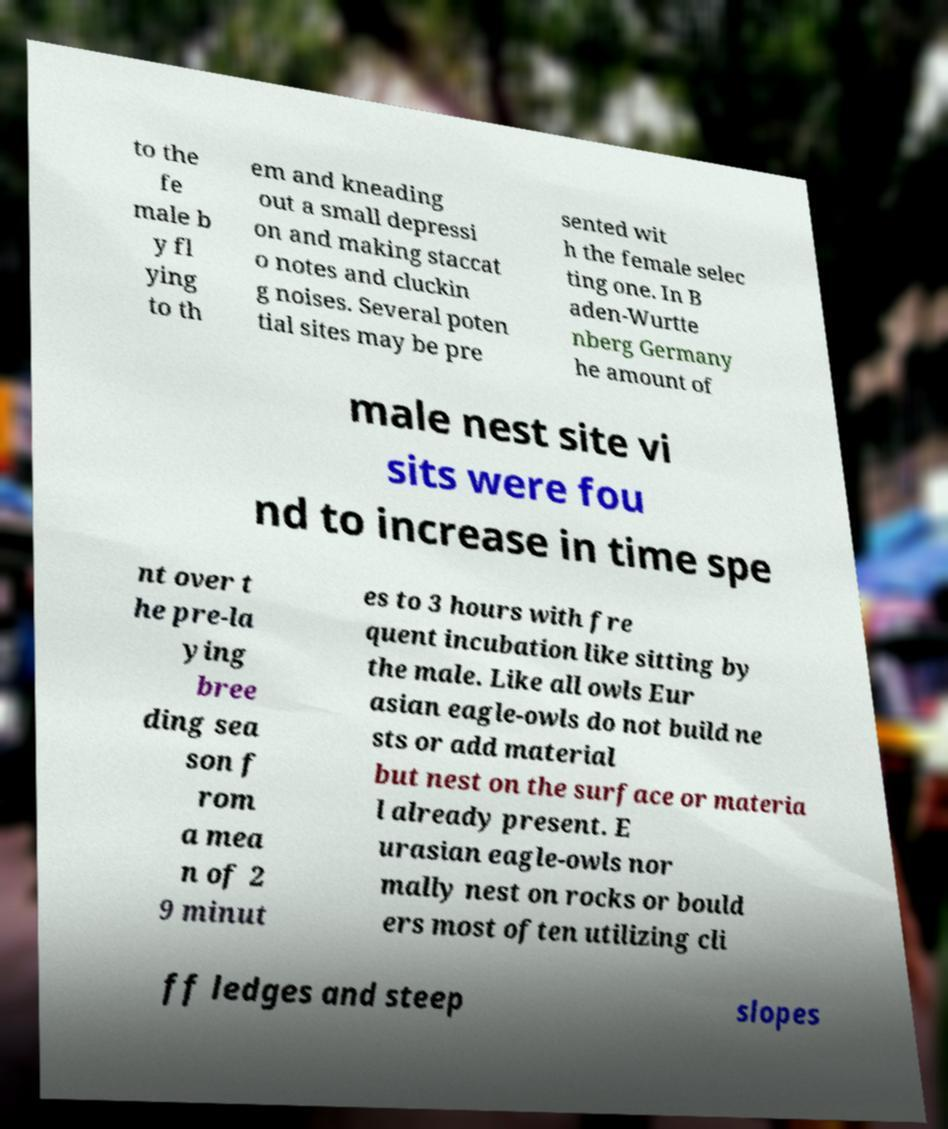Can you accurately transcribe the text from the provided image for me? to the fe male b y fl ying to th em and kneading out a small depressi on and making staccat o notes and cluckin g noises. Several poten tial sites may be pre sented wit h the female selec ting one. In B aden-Wurtte nberg Germany he amount of male nest site vi sits were fou nd to increase in time spe nt over t he pre-la ying bree ding sea son f rom a mea n of 2 9 minut es to 3 hours with fre quent incubation like sitting by the male. Like all owls Eur asian eagle-owls do not build ne sts or add material but nest on the surface or materia l already present. E urasian eagle-owls nor mally nest on rocks or bould ers most often utilizing cli ff ledges and steep slopes 